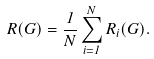<formula> <loc_0><loc_0><loc_500><loc_500>R ( G ) = \frac { 1 } { N } \sum _ { i = 1 } ^ { N } R _ { i } ( G ) .</formula> 